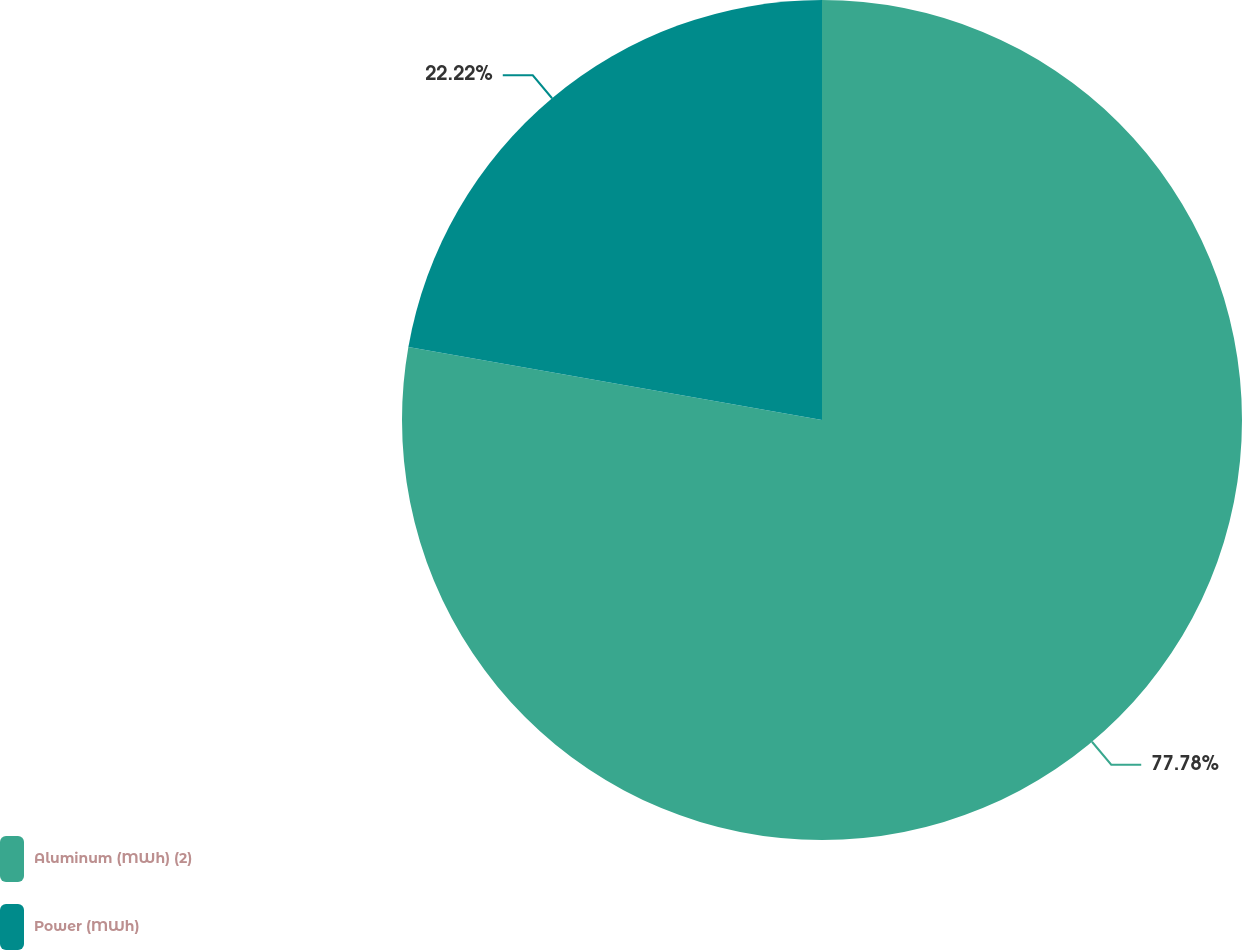Convert chart. <chart><loc_0><loc_0><loc_500><loc_500><pie_chart><fcel>Aluminum (MWh) (2)<fcel>Power (MWh)<nl><fcel>77.78%<fcel>22.22%<nl></chart> 